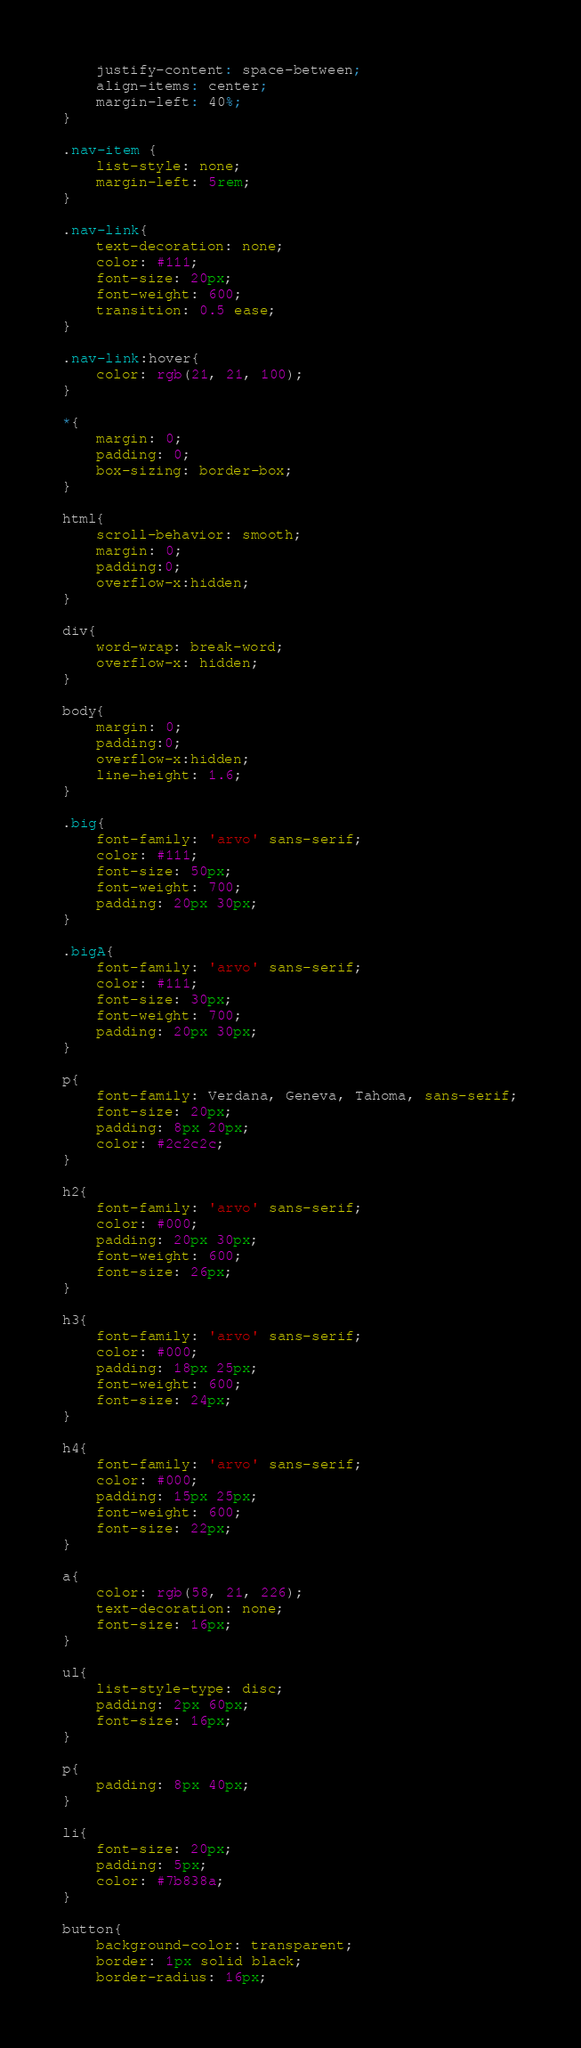Convert code to text. <code><loc_0><loc_0><loc_500><loc_500><_CSS_>    justify-content: space-between;
    align-items: center;
    margin-left: 40%;  
}

.nav-item {
    list-style: none;
    margin-left: 5rem;
}

.nav-link{ 
    text-decoration: none;
    color: #111;
    font-size: 20px;
    font-weight: 600;
    transition: 0.5 ease;
}

.nav-link:hover{
    color: rgb(21, 21, 100);
}

*{
    margin: 0;
    padding: 0;
    box-sizing: border-box;
}

html{
    scroll-behavior: smooth;
    margin: 0;
    padding:0;
    overflow-x:hidden;
}

div{
    word-wrap: break-word;
    overflow-x: hidden;
}

body{
    margin: 0;
    padding:0;
    overflow-x:hidden;
    line-height: 1.6;
}

.big{
    font-family: 'arvo' sans-serif;
    color: #111;
    font-size: 50px;
    font-weight: 700;
    padding: 20px 30px;
}

.bigA{
    font-family: 'arvo' sans-serif;
    color: #111;
    font-size: 30px;
    font-weight: 700;
    padding: 20px 30px;
}

p{
    font-family: Verdana, Geneva, Tahoma, sans-serif;
    font-size: 20px;
    padding: 8px 20px;
    color: #2c2c2c;
}

h2{
    font-family: 'arvo' sans-serif;
    color: #000;
    padding: 20px 30px;
    font-weight: 600;
    font-size: 26px;
}

h3{
    font-family: 'arvo' sans-serif;
    color: #000;
    padding: 18px 25px;
    font-weight: 600;
    font-size: 24px;
}

h4{
    font-family: 'arvo' sans-serif;
    color: #000;
    padding: 15px 25px;
    font-weight: 600;
    font-size: 22px;
}

a{
    color: rgb(58, 21, 226);
    text-decoration: none;
    font-size: 16px;
}

ul{
    list-style-type: disc;
    padding: 2px 60px;
    font-size: 16px;
}

p{
    padding: 8px 40px;
}

li{
    font-size: 20px;
    padding: 5px;
    color: #7b838a;
}

button{
    background-color: transparent;
    border: 1px solid black;
    border-radius: 16px;</code> 